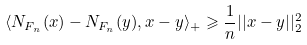Convert formula to latex. <formula><loc_0><loc_0><loc_500><loc_500>\langle N _ { F _ { n } } ( x ) - N _ { F _ { n } } ( y ) , x - y \rangle _ { + } \geqslant \frac { 1 } { n } | | x - y | | _ { 2 } ^ { 2 }</formula> 